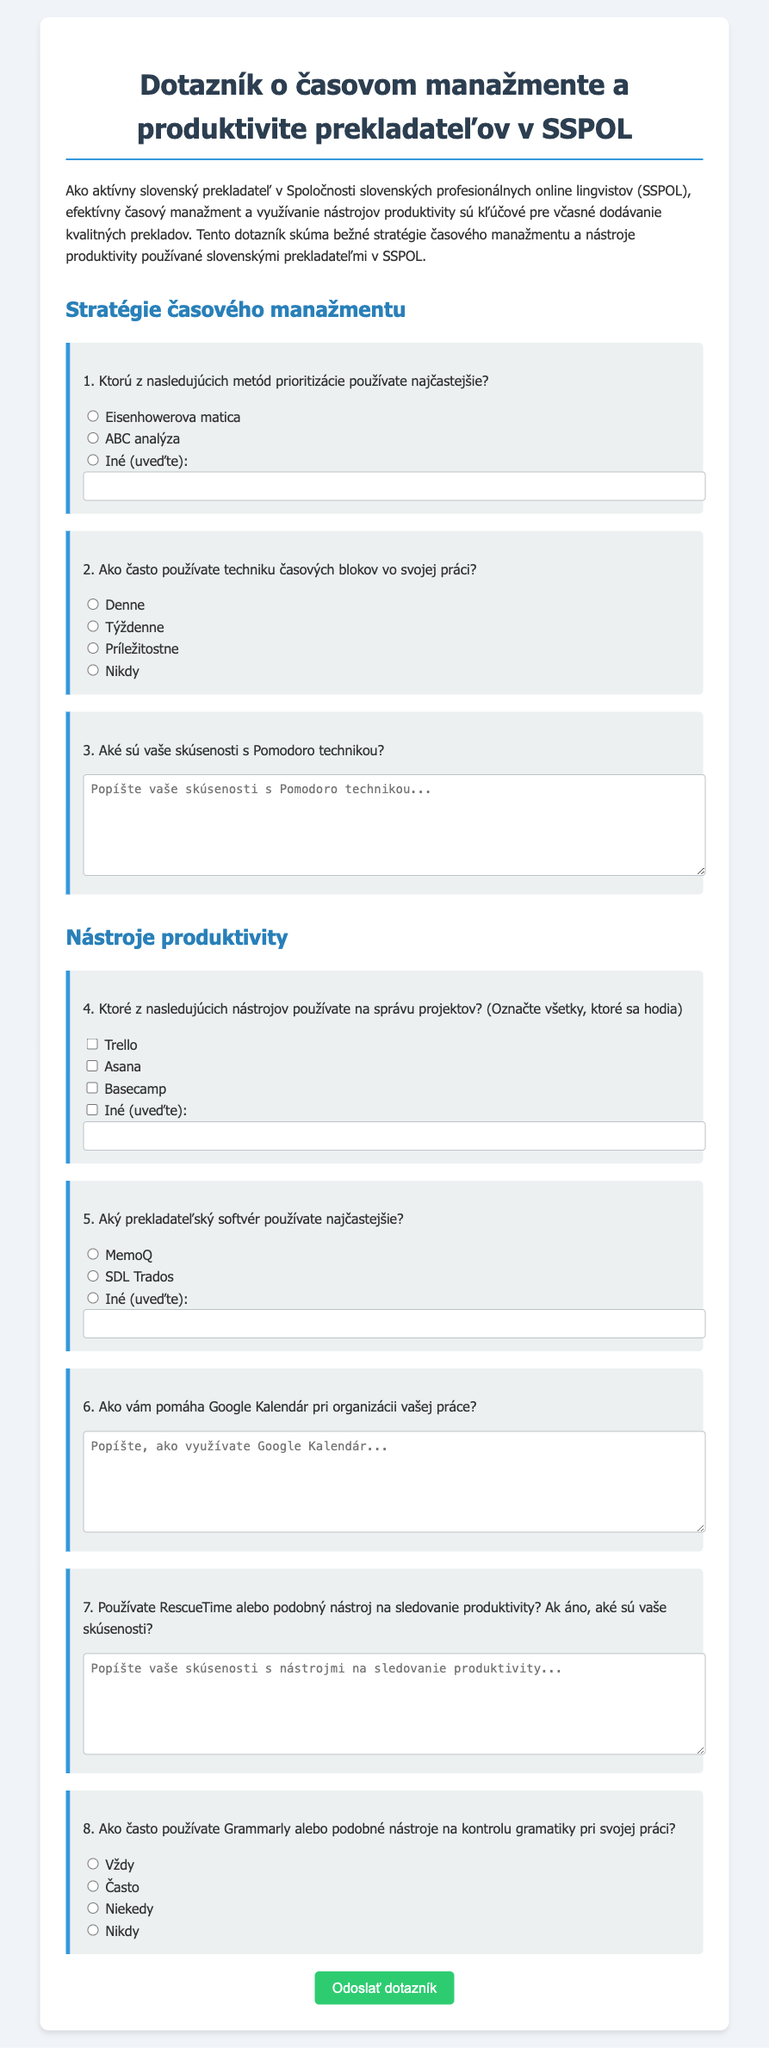What is the title of the document? The title is displayed in the header of the document, specifically in the <title> tag.
Answer: Dotazník o časovom manažmente a produktivite prekladateľov v SSPOL What is the primary objective of the questionnaire? The objective is outlined in the introductory paragraph that explains its purpose.
Answer: Skúma bežné stratégie časového manažmentu a nástroje produktivity Which prioritization method is listed first? The order of the methods is present in the first question about prioritization in the document.
Answer: Eisenhowerova matica What technique is mentioned for time management? The document lists various time management techniques in the corresponding section.
Answer: Technika časových blokov How often is the Pomodoro technique discussed? It is referenced in the third question that asks about experiences with the technique.
Answer: Experiences What project management tool is not mentioned? The question about project management tools includes various options to check, and we can deduce that some common tools are not listed.
Answer: Not applicable What percentage of respondents is likely to use Google Calendar? The answer regarding its usage can be inferred from the question about how it helps organize work.
Answer: Personal evaluation What type of grammar checking tools does the questionnaire reference? The last question references tools specifically designed for grammar checking.
Answer: Grammarly or podobné nástroje How is the questionnaire submitted? The submission method is indicated by the final button in the document.
Answer: Kliknutím na „Odoslať dotazník“ 